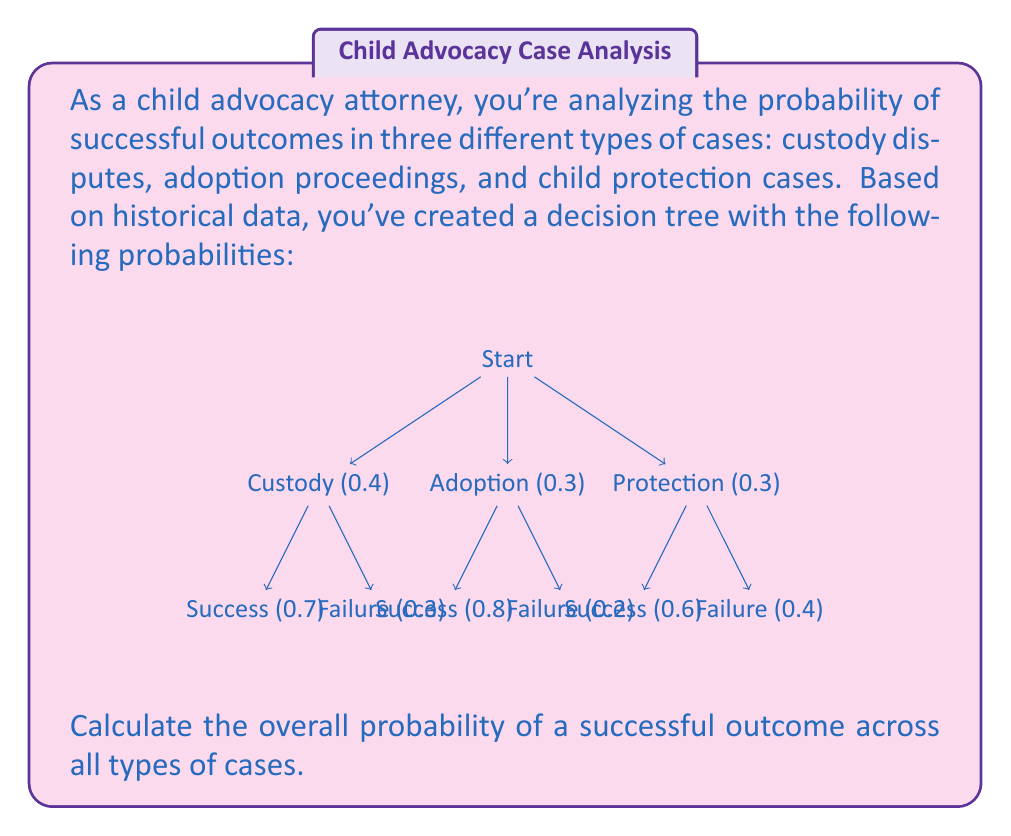Give your solution to this math problem. To calculate the overall probability of a successful outcome, we need to use the law of total probability. We'll multiply the probability of each case type by its respective success probability and then sum these results.

Step 1: Calculate the probability of success for each case type.

Custody cases:
$P(\text{Custody and Success}) = 0.4 \times 0.7 = 0.28$

Adoption cases:
$P(\text{Adoption and Success}) = 0.3 \times 0.8 = 0.24$

Child protection cases:
$P(\text{Protection and Success}) = 0.3 \times 0.6 = 0.18$

Step 2: Sum the probabilities of success for all case types.

$P(\text{Success}) = P(\text{Custody and Success}) + P(\text{Adoption and Success}) + P(\text{Protection and Success})$

$P(\text{Success}) = 0.28 + 0.24 + 0.18 = 0.70$

Therefore, the overall probability of a successful outcome across all types of cases is 0.70 or 70%.
Answer: 0.70 